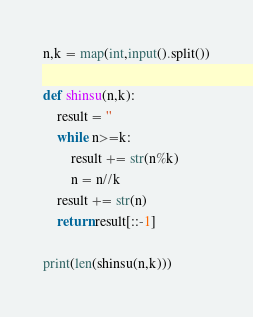Convert code to text. <code><loc_0><loc_0><loc_500><loc_500><_Python_>n,k = map(int,input().split())

def shinsu(n,k):
    result = ''
    while n>=k:
        result += str(n%k)
        n = n//k
    result += str(n)
    return result[::-1]

print(len(shinsu(n,k)))</code> 